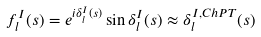<formula> <loc_0><loc_0><loc_500><loc_500>f _ { l } ^ { I } ( s ) = e ^ { i \delta _ { l } ^ { I } ( s ) } \sin \delta _ { l } ^ { I } ( s ) \approx \delta _ { l } ^ { I , C h P T } ( s )</formula> 